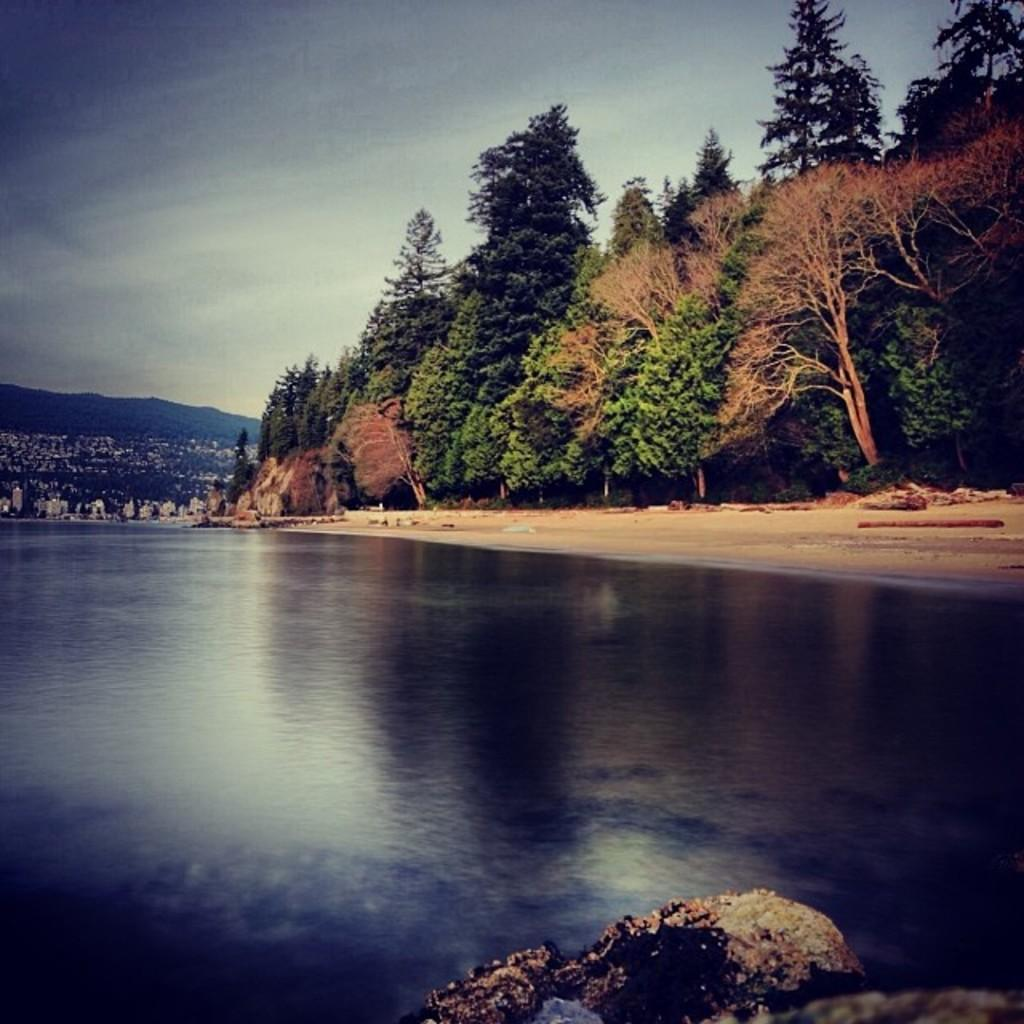What type of natural feature is at the bottom of the image? There is a sea at the bottom of the image. What can be seen in the background of the image? There are trees, buildings, and mountains in the background of the image. What is visible at the top of the image? The sky is visible at the top of the image. What type of plants are being discussed by the committee in the image? There is no committee or discussion of plants present in the image. 